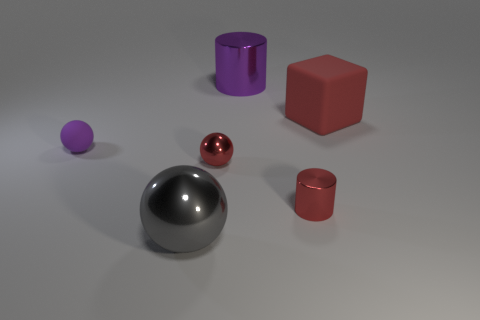There is a thing that is behind the small purple ball and to the left of the red matte thing; what color is it?
Your response must be concise. Purple. What size is the rubber thing that is to the left of the shiny ball to the right of the large object on the left side of the purple metallic object?
Offer a very short reply. Small. What number of objects are either large objects behind the large shiny sphere or metallic things on the right side of the big gray thing?
Ensure brevity in your answer.  4. The large matte thing has what shape?
Offer a terse response. Cube. How many other objects are there of the same material as the gray thing?
Your response must be concise. 3. There is another red object that is the same shape as the small matte object; what size is it?
Provide a succinct answer. Small. What is the cylinder that is behind the large red matte cube right of the object that is left of the gray object made of?
Give a very brief answer. Metal. Are any purple rubber spheres visible?
Your answer should be very brief. Yes. There is a small cylinder; is its color the same as the ball that is to the right of the big metal sphere?
Offer a very short reply. Yes. What color is the big cylinder?
Your answer should be compact. Purple. 